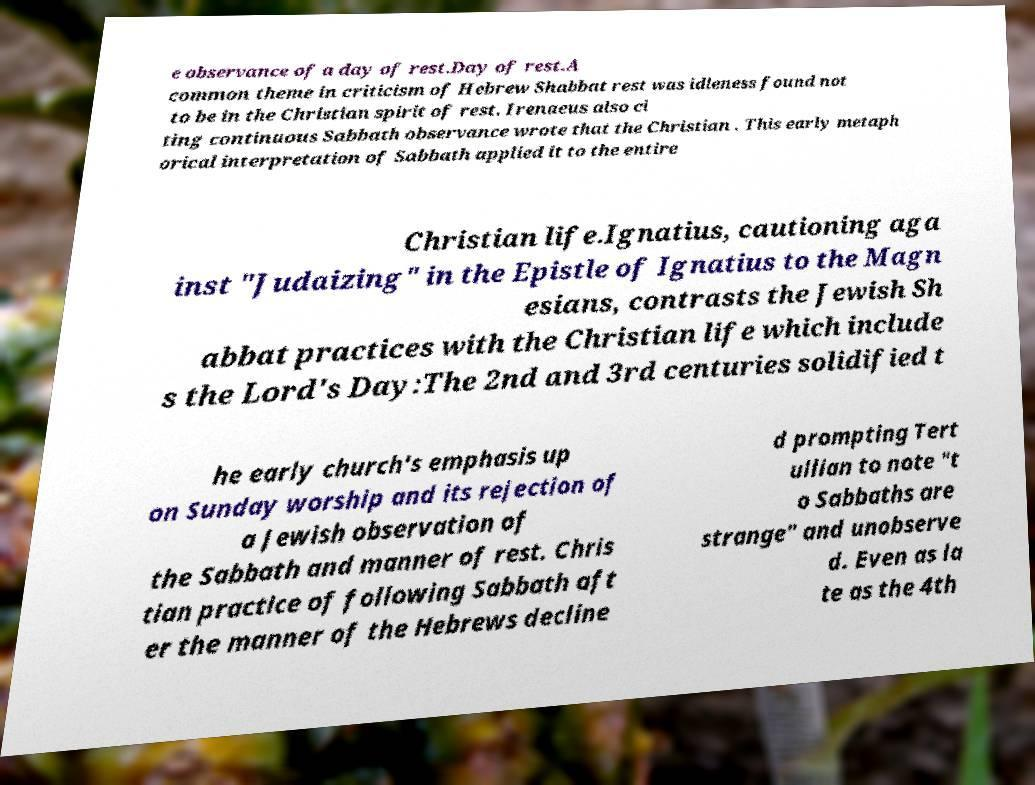For documentation purposes, I need the text within this image transcribed. Could you provide that? e observance of a day of rest.Day of rest.A common theme in criticism of Hebrew Shabbat rest was idleness found not to be in the Christian spirit of rest. Irenaeus also ci ting continuous Sabbath observance wrote that the Christian . This early metaph orical interpretation of Sabbath applied it to the entire Christian life.Ignatius, cautioning aga inst "Judaizing" in the Epistle of Ignatius to the Magn esians, contrasts the Jewish Sh abbat practices with the Christian life which include s the Lord's Day:The 2nd and 3rd centuries solidified t he early church's emphasis up on Sunday worship and its rejection of a Jewish observation of the Sabbath and manner of rest. Chris tian practice of following Sabbath aft er the manner of the Hebrews decline d prompting Tert ullian to note "t o Sabbaths are strange" and unobserve d. Even as la te as the 4th 